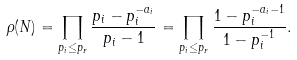Convert formula to latex. <formula><loc_0><loc_0><loc_500><loc_500>\rho ( N ) = \prod _ { p _ { i } \leq p _ { r } } \frac { p _ { i } - p _ { i } ^ { - a _ { i } } } { p _ { i } - 1 } = \prod _ { p _ { i } \leq p _ { r } } \frac { 1 - p _ { i } ^ { - a _ { i } - 1 } } { 1 - p _ { i } ^ { - 1 } } .</formula> 